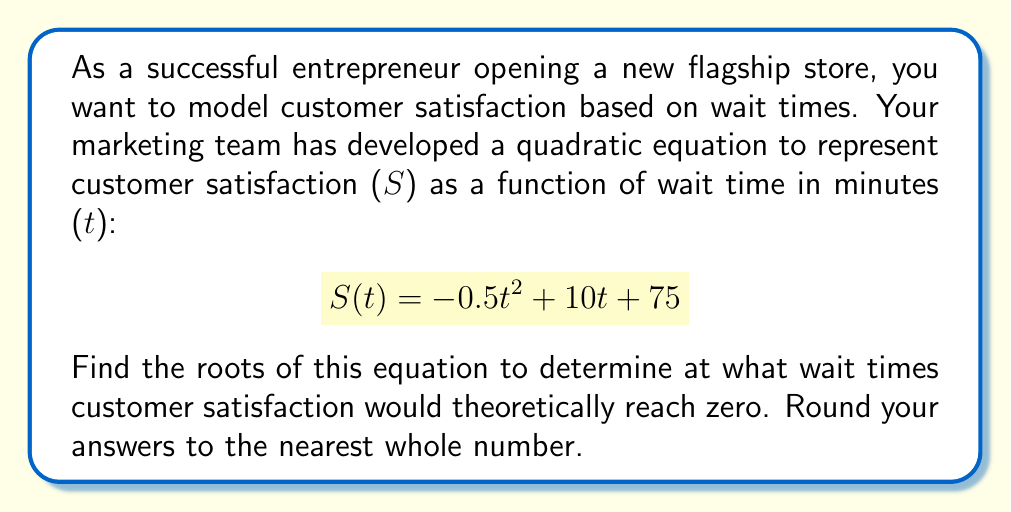Teach me how to tackle this problem. To find the roots of the quadratic equation, we need to solve $S(t) = 0$:

$$ -0.5t^2 + 10t + 75 = 0 $$

We can solve this using the quadratic formula: $t = \frac{-b \pm \sqrt{b^2 - 4ac}}{2a}$

Where $a = -0.5$, $b = 10$, and $c = 75$

Step 1: Calculate the discriminant
$$ b^2 - 4ac = 10^2 - 4(-0.5)(75) = 100 + 150 = 250 $$

Step 2: Apply the quadratic formula
$$ t = \frac{-10 \pm \sqrt{250}}{2(-0.5)} $$

Step 3: Simplify
$$ t = \frac{-10 \pm 5\sqrt{10}}{-1} = 10 \pm 5\sqrt{10} $$

Step 4: Calculate the two solutions
$t_1 = 10 + 5\sqrt{10} \approx 25.8$ minutes
$t_2 = 10 - 5\sqrt{10} \approx -5.8$ minutes

Step 5: Round to the nearest whole number
$t_1 \approx 26$ minutes
$t_2 \approx -6$ minutes

Since wait times cannot be negative, we discard the negative solution.
Answer: The root of the quadratic equation modeling customer satisfaction is approximately 26 minutes. This means customer satisfaction would theoretically reach zero when the wait time is 26 minutes. 